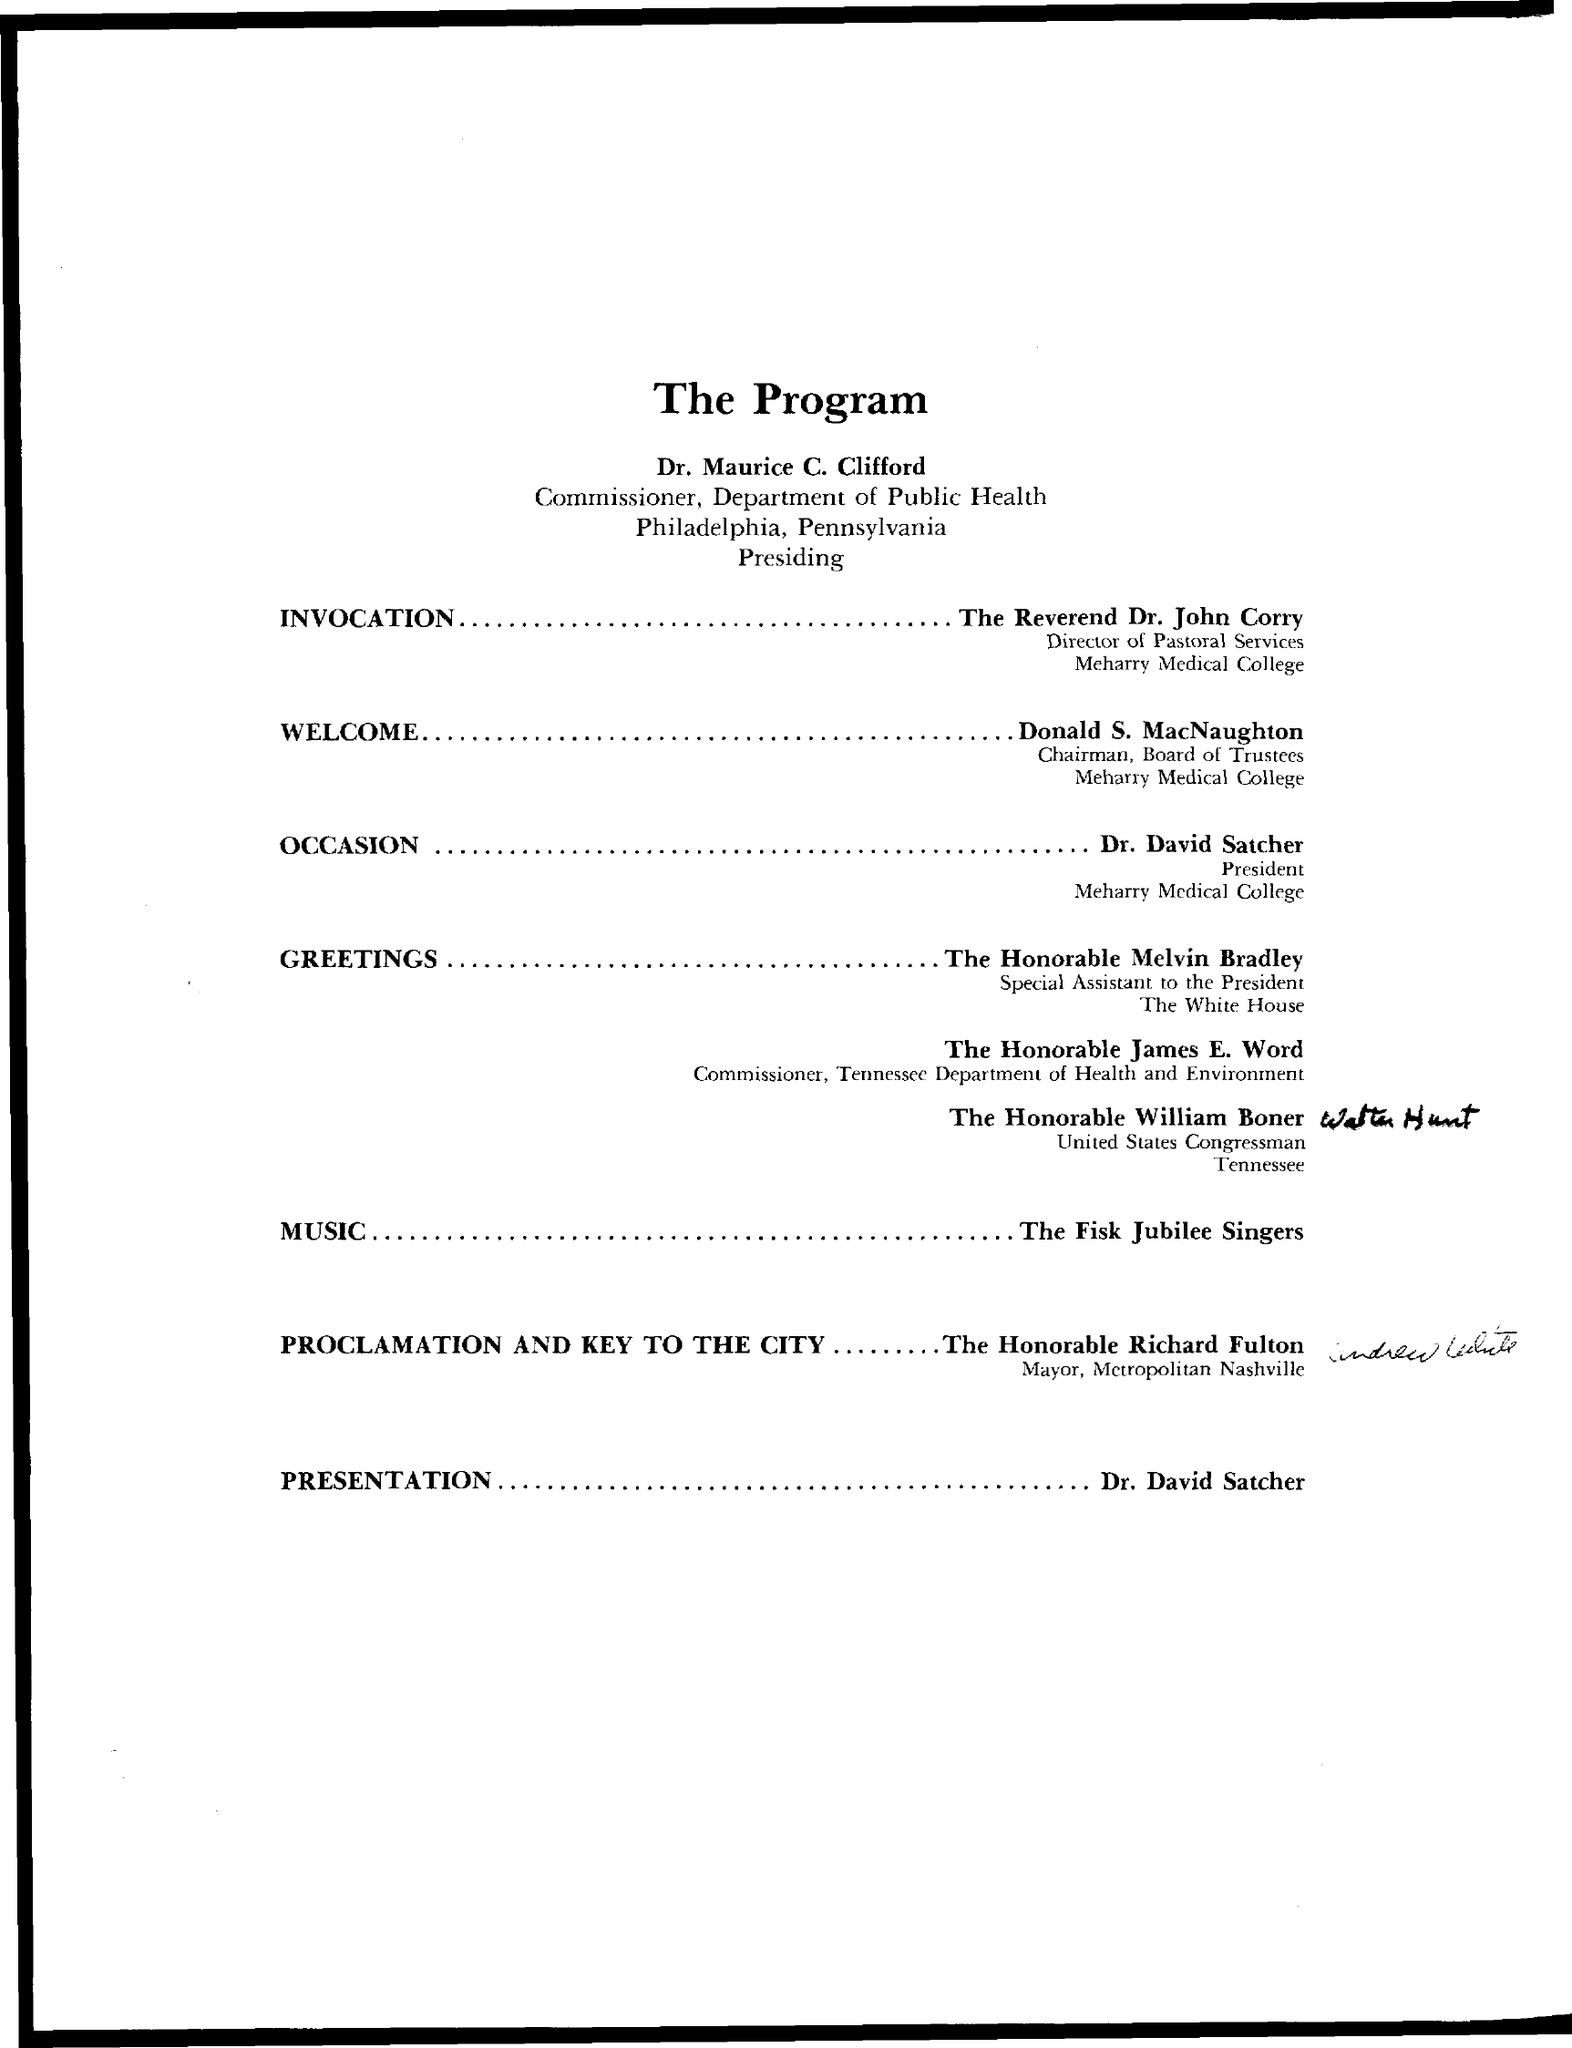What is the title of the document?
Provide a short and direct response. The Program. 